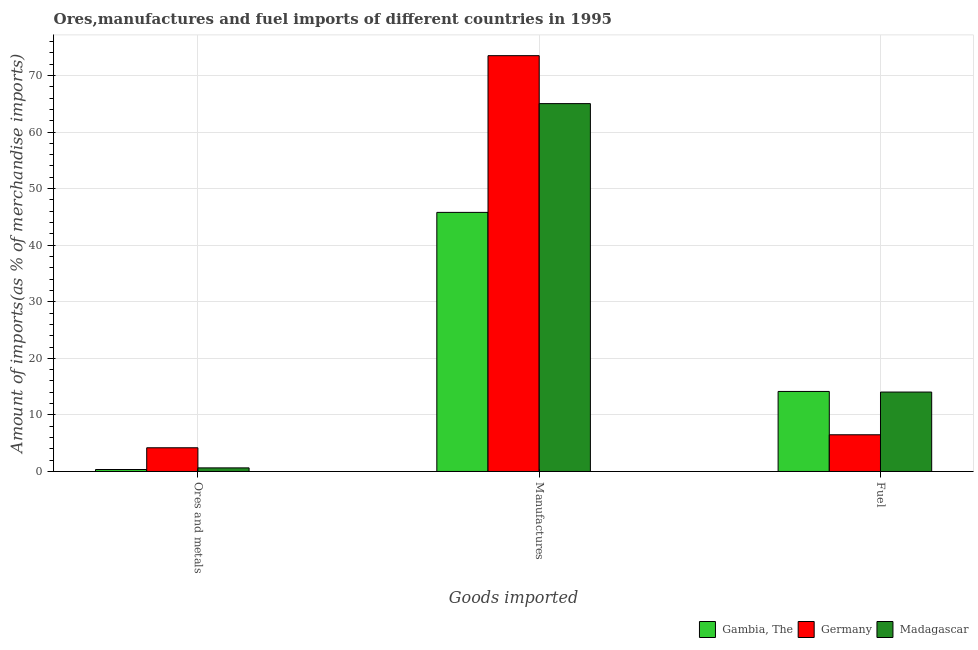Are the number of bars per tick equal to the number of legend labels?
Offer a very short reply. Yes. How many bars are there on the 1st tick from the left?
Give a very brief answer. 3. What is the label of the 2nd group of bars from the left?
Offer a very short reply. Manufactures. What is the percentage of fuel imports in Germany?
Ensure brevity in your answer.  6.49. Across all countries, what is the maximum percentage of fuel imports?
Ensure brevity in your answer.  14.15. Across all countries, what is the minimum percentage of fuel imports?
Keep it short and to the point. 6.49. In which country was the percentage of fuel imports maximum?
Give a very brief answer. Gambia, The. What is the total percentage of manufactures imports in the graph?
Give a very brief answer. 184.31. What is the difference between the percentage of fuel imports in Germany and that in Gambia, The?
Your answer should be compact. -7.66. What is the difference between the percentage of fuel imports in Germany and the percentage of manufactures imports in Madagascar?
Your response must be concise. -58.53. What is the average percentage of ores and metals imports per country?
Provide a succinct answer. 1.73. What is the difference between the percentage of manufactures imports and percentage of ores and metals imports in Madagascar?
Your answer should be very brief. 64.38. In how many countries, is the percentage of fuel imports greater than 20 %?
Offer a very short reply. 0. What is the ratio of the percentage of fuel imports in Madagascar to that in Gambia, The?
Your answer should be very brief. 0.99. What is the difference between the highest and the second highest percentage of manufactures imports?
Make the answer very short. 8.48. What is the difference between the highest and the lowest percentage of fuel imports?
Make the answer very short. 7.66. In how many countries, is the percentage of ores and metals imports greater than the average percentage of ores and metals imports taken over all countries?
Provide a succinct answer. 1. What does the 1st bar from the left in Ores and metals represents?
Keep it short and to the point. Gambia, The. What does the 1st bar from the right in Fuel represents?
Provide a succinct answer. Madagascar. Are all the bars in the graph horizontal?
Give a very brief answer. No. How many countries are there in the graph?
Offer a very short reply. 3. What is the difference between two consecutive major ticks on the Y-axis?
Provide a succinct answer. 10. Are the values on the major ticks of Y-axis written in scientific E-notation?
Provide a succinct answer. No. Does the graph contain grids?
Ensure brevity in your answer.  Yes. Where does the legend appear in the graph?
Keep it short and to the point. Bottom right. How are the legend labels stacked?
Provide a succinct answer. Horizontal. What is the title of the graph?
Keep it short and to the point. Ores,manufactures and fuel imports of different countries in 1995. What is the label or title of the X-axis?
Make the answer very short. Goods imported. What is the label or title of the Y-axis?
Provide a succinct answer. Amount of imports(as % of merchandise imports). What is the Amount of imports(as % of merchandise imports) in Gambia, The in Ores and metals?
Keep it short and to the point. 0.35. What is the Amount of imports(as % of merchandise imports) in Germany in Ores and metals?
Keep it short and to the point. 4.19. What is the Amount of imports(as % of merchandise imports) in Madagascar in Ores and metals?
Ensure brevity in your answer.  0.64. What is the Amount of imports(as % of merchandise imports) of Gambia, The in Manufactures?
Provide a succinct answer. 45.8. What is the Amount of imports(as % of merchandise imports) of Germany in Manufactures?
Keep it short and to the point. 73.5. What is the Amount of imports(as % of merchandise imports) in Madagascar in Manufactures?
Your answer should be very brief. 65.02. What is the Amount of imports(as % of merchandise imports) in Gambia, The in Fuel?
Your answer should be compact. 14.15. What is the Amount of imports(as % of merchandise imports) of Germany in Fuel?
Offer a terse response. 6.49. What is the Amount of imports(as % of merchandise imports) in Madagascar in Fuel?
Your response must be concise. 14.04. Across all Goods imported, what is the maximum Amount of imports(as % of merchandise imports) of Gambia, The?
Offer a very short reply. 45.8. Across all Goods imported, what is the maximum Amount of imports(as % of merchandise imports) of Germany?
Provide a succinct answer. 73.5. Across all Goods imported, what is the maximum Amount of imports(as % of merchandise imports) in Madagascar?
Keep it short and to the point. 65.02. Across all Goods imported, what is the minimum Amount of imports(as % of merchandise imports) of Gambia, The?
Provide a succinct answer. 0.35. Across all Goods imported, what is the minimum Amount of imports(as % of merchandise imports) of Germany?
Keep it short and to the point. 4.19. Across all Goods imported, what is the minimum Amount of imports(as % of merchandise imports) in Madagascar?
Provide a succinct answer. 0.64. What is the total Amount of imports(as % of merchandise imports) in Gambia, The in the graph?
Ensure brevity in your answer.  60.29. What is the total Amount of imports(as % of merchandise imports) of Germany in the graph?
Ensure brevity in your answer.  84.18. What is the total Amount of imports(as % of merchandise imports) of Madagascar in the graph?
Give a very brief answer. 79.7. What is the difference between the Amount of imports(as % of merchandise imports) of Gambia, The in Ores and metals and that in Manufactures?
Offer a terse response. -45.45. What is the difference between the Amount of imports(as % of merchandise imports) in Germany in Ores and metals and that in Manufactures?
Provide a short and direct response. -69.31. What is the difference between the Amount of imports(as % of merchandise imports) of Madagascar in Ores and metals and that in Manufactures?
Ensure brevity in your answer.  -64.38. What is the difference between the Amount of imports(as % of merchandise imports) in Gambia, The in Ores and metals and that in Fuel?
Your response must be concise. -13.8. What is the difference between the Amount of imports(as % of merchandise imports) in Germany in Ores and metals and that in Fuel?
Offer a terse response. -2.3. What is the difference between the Amount of imports(as % of merchandise imports) of Madagascar in Ores and metals and that in Fuel?
Give a very brief answer. -13.4. What is the difference between the Amount of imports(as % of merchandise imports) in Gambia, The in Manufactures and that in Fuel?
Provide a short and direct response. 31.65. What is the difference between the Amount of imports(as % of merchandise imports) of Germany in Manufactures and that in Fuel?
Keep it short and to the point. 67.01. What is the difference between the Amount of imports(as % of merchandise imports) in Madagascar in Manufactures and that in Fuel?
Offer a terse response. 50.98. What is the difference between the Amount of imports(as % of merchandise imports) in Gambia, The in Ores and metals and the Amount of imports(as % of merchandise imports) in Germany in Manufactures?
Your response must be concise. -73.15. What is the difference between the Amount of imports(as % of merchandise imports) of Gambia, The in Ores and metals and the Amount of imports(as % of merchandise imports) of Madagascar in Manufactures?
Provide a succinct answer. -64.67. What is the difference between the Amount of imports(as % of merchandise imports) in Germany in Ores and metals and the Amount of imports(as % of merchandise imports) in Madagascar in Manufactures?
Offer a very short reply. -60.83. What is the difference between the Amount of imports(as % of merchandise imports) of Gambia, The in Ores and metals and the Amount of imports(as % of merchandise imports) of Germany in Fuel?
Provide a short and direct response. -6.14. What is the difference between the Amount of imports(as % of merchandise imports) in Gambia, The in Ores and metals and the Amount of imports(as % of merchandise imports) in Madagascar in Fuel?
Give a very brief answer. -13.69. What is the difference between the Amount of imports(as % of merchandise imports) of Germany in Ores and metals and the Amount of imports(as % of merchandise imports) of Madagascar in Fuel?
Offer a very short reply. -9.85. What is the difference between the Amount of imports(as % of merchandise imports) of Gambia, The in Manufactures and the Amount of imports(as % of merchandise imports) of Germany in Fuel?
Give a very brief answer. 39.31. What is the difference between the Amount of imports(as % of merchandise imports) of Gambia, The in Manufactures and the Amount of imports(as % of merchandise imports) of Madagascar in Fuel?
Your answer should be very brief. 31.76. What is the difference between the Amount of imports(as % of merchandise imports) in Germany in Manufactures and the Amount of imports(as % of merchandise imports) in Madagascar in Fuel?
Your answer should be very brief. 59.46. What is the average Amount of imports(as % of merchandise imports) of Gambia, The per Goods imported?
Keep it short and to the point. 20.1. What is the average Amount of imports(as % of merchandise imports) of Germany per Goods imported?
Provide a short and direct response. 28.06. What is the average Amount of imports(as % of merchandise imports) in Madagascar per Goods imported?
Offer a terse response. 26.57. What is the difference between the Amount of imports(as % of merchandise imports) of Gambia, The and Amount of imports(as % of merchandise imports) of Germany in Ores and metals?
Provide a succinct answer. -3.84. What is the difference between the Amount of imports(as % of merchandise imports) of Gambia, The and Amount of imports(as % of merchandise imports) of Madagascar in Ores and metals?
Provide a succinct answer. -0.29. What is the difference between the Amount of imports(as % of merchandise imports) in Germany and Amount of imports(as % of merchandise imports) in Madagascar in Ores and metals?
Offer a very short reply. 3.55. What is the difference between the Amount of imports(as % of merchandise imports) in Gambia, The and Amount of imports(as % of merchandise imports) in Germany in Manufactures?
Give a very brief answer. -27.7. What is the difference between the Amount of imports(as % of merchandise imports) in Gambia, The and Amount of imports(as % of merchandise imports) in Madagascar in Manufactures?
Make the answer very short. -19.23. What is the difference between the Amount of imports(as % of merchandise imports) of Germany and Amount of imports(as % of merchandise imports) of Madagascar in Manufactures?
Keep it short and to the point. 8.48. What is the difference between the Amount of imports(as % of merchandise imports) of Gambia, The and Amount of imports(as % of merchandise imports) of Germany in Fuel?
Ensure brevity in your answer.  7.66. What is the difference between the Amount of imports(as % of merchandise imports) in Gambia, The and Amount of imports(as % of merchandise imports) in Madagascar in Fuel?
Offer a very short reply. 0.11. What is the difference between the Amount of imports(as % of merchandise imports) of Germany and Amount of imports(as % of merchandise imports) of Madagascar in Fuel?
Offer a terse response. -7.55. What is the ratio of the Amount of imports(as % of merchandise imports) of Gambia, The in Ores and metals to that in Manufactures?
Provide a short and direct response. 0.01. What is the ratio of the Amount of imports(as % of merchandise imports) in Germany in Ores and metals to that in Manufactures?
Your answer should be very brief. 0.06. What is the ratio of the Amount of imports(as % of merchandise imports) in Madagascar in Ores and metals to that in Manufactures?
Your response must be concise. 0.01. What is the ratio of the Amount of imports(as % of merchandise imports) of Gambia, The in Ores and metals to that in Fuel?
Ensure brevity in your answer.  0.02. What is the ratio of the Amount of imports(as % of merchandise imports) in Germany in Ores and metals to that in Fuel?
Ensure brevity in your answer.  0.65. What is the ratio of the Amount of imports(as % of merchandise imports) of Madagascar in Ores and metals to that in Fuel?
Provide a succinct answer. 0.05. What is the ratio of the Amount of imports(as % of merchandise imports) of Gambia, The in Manufactures to that in Fuel?
Provide a succinct answer. 3.24. What is the ratio of the Amount of imports(as % of merchandise imports) in Germany in Manufactures to that in Fuel?
Your response must be concise. 11.33. What is the ratio of the Amount of imports(as % of merchandise imports) in Madagascar in Manufactures to that in Fuel?
Provide a succinct answer. 4.63. What is the difference between the highest and the second highest Amount of imports(as % of merchandise imports) in Gambia, The?
Make the answer very short. 31.65. What is the difference between the highest and the second highest Amount of imports(as % of merchandise imports) in Germany?
Offer a terse response. 67.01. What is the difference between the highest and the second highest Amount of imports(as % of merchandise imports) in Madagascar?
Offer a terse response. 50.98. What is the difference between the highest and the lowest Amount of imports(as % of merchandise imports) in Gambia, The?
Provide a succinct answer. 45.45. What is the difference between the highest and the lowest Amount of imports(as % of merchandise imports) in Germany?
Offer a terse response. 69.31. What is the difference between the highest and the lowest Amount of imports(as % of merchandise imports) in Madagascar?
Give a very brief answer. 64.38. 